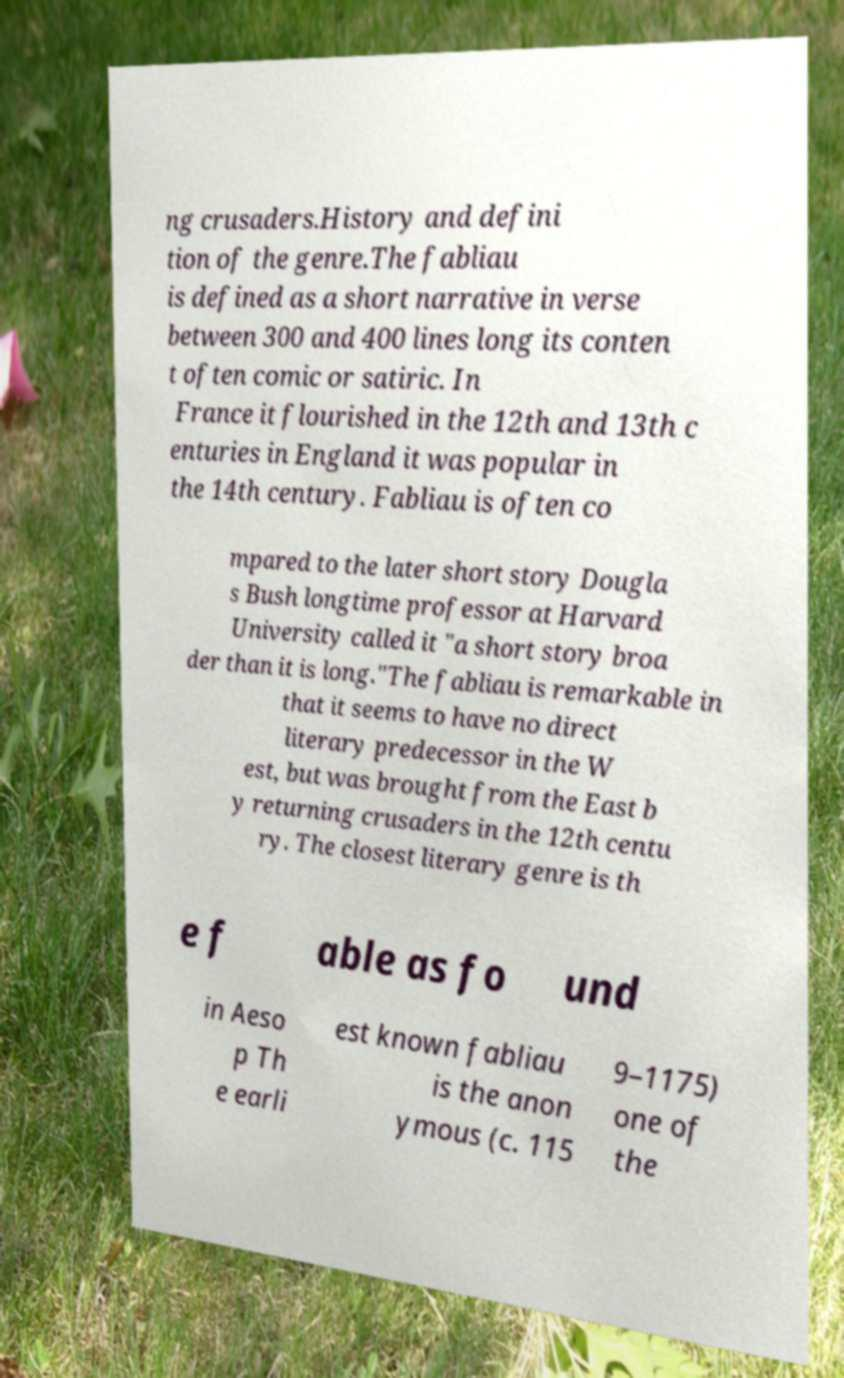There's text embedded in this image that I need extracted. Can you transcribe it verbatim? ng crusaders.History and defini tion of the genre.The fabliau is defined as a short narrative in verse between 300 and 400 lines long its conten t often comic or satiric. In France it flourished in the 12th and 13th c enturies in England it was popular in the 14th century. Fabliau is often co mpared to the later short story Dougla s Bush longtime professor at Harvard University called it "a short story broa der than it is long."The fabliau is remarkable in that it seems to have no direct literary predecessor in the W est, but was brought from the East b y returning crusaders in the 12th centu ry. The closest literary genre is th e f able as fo und in Aeso p Th e earli est known fabliau is the anon ymous (c. 115 9–1175) one of the 